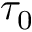Convert formula to latex. <formula><loc_0><loc_0><loc_500><loc_500>\tau _ { 0 }</formula> 